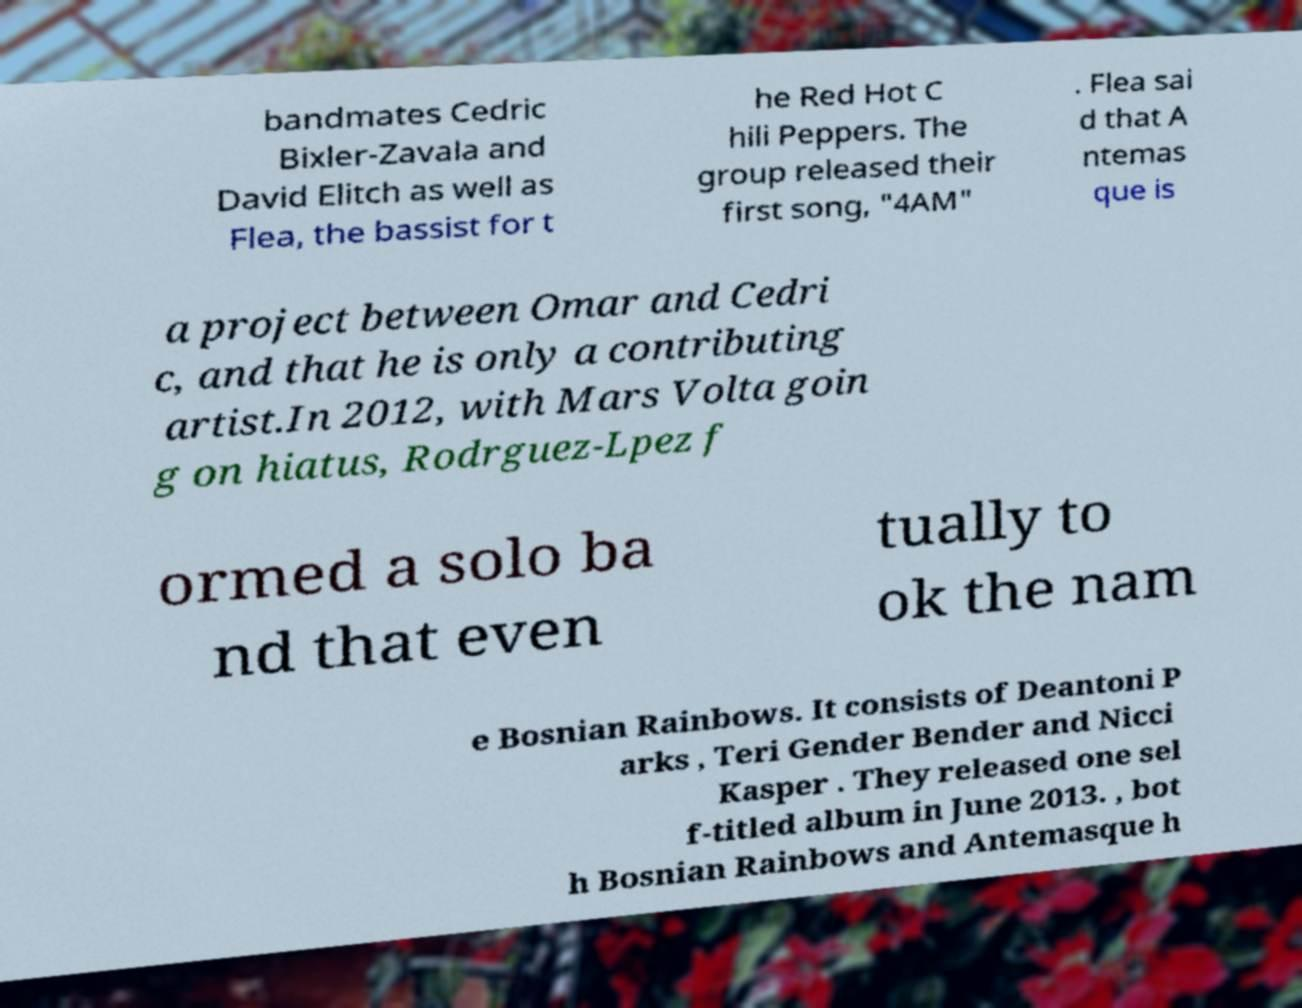Please identify and transcribe the text found in this image. bandmates Cedric Bixler-Zavala and David Elitch as well as Flea, the bassist for t he Red Hot C hili Peppers. The group released their first song, "4AM" . Flea sai d that A ntemas que is a project between Omar and Cedri c, and that he is only a contributing artist.In 2012, with Mars Volta goin g on hiatus, Rodrguez-Lpez f ormed a solo ba nd that even tually to ok the nam e Bosnian Rainbows. It consists of Deantoni P arks , Teri Gender Bender and Nicci Kasper . They released one sel f-titled album in June 2013. , bot h Bosnian Rainbows and Antemasque h 